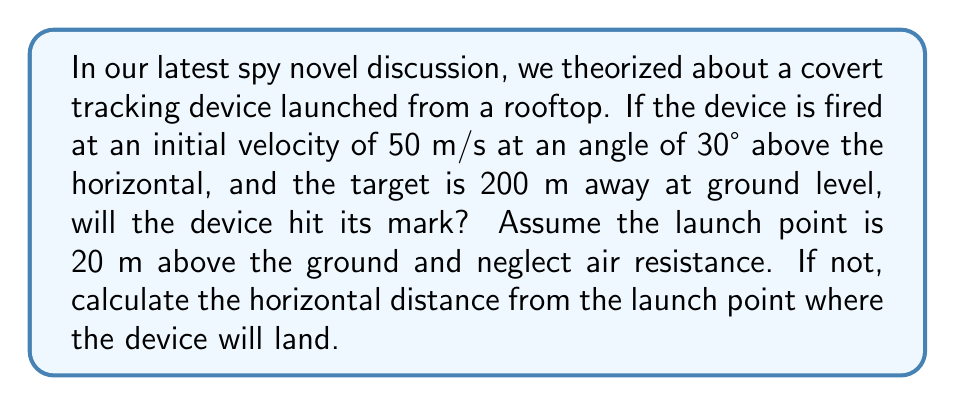Solve this math problem. Let's approach this step-by-step using projectile motion equations:

1) First, let's break down the initial velocity into its components:
   $v_{0x} = v_0 \cos \theta = 50 \cos 30° = 43.3$ m/s
   $v_{0y} = v_0 \sin \theta = 50 \sin 30° = 25$ m/s

2) The time of flight can be calculated using the vertical motion equation:
   $y = y_0 + v_{0y}t - \frac{1}{2}gt^2$
   Where $y = 0$ (ground level), $y_0 = 20$ m, $v_{0y} = 25$ m/s, and $g = 9.8$ m/s²

3) Substituting these values:
   $0 = 20 + 25t - 4.9t^2$
   $4.9t^2 - 25t - 20 = 0$

4) Solving this quadratic equation:
   $t = \frac{25 \pm \sqrt{25^2 + 4(4.9)(20)}}{2(4.9)} = \frac{25 \pm \sqrt{1225}}{9.8}$
   $t = 3.56$ seconds (we take the positive root as time can't be negative)

5) Now, we can calculate the horizontal distance traveled:
   $x = v_{0x}t = 43.3 \times 3.56 = 154.1$ m

6) The device will land 154.1 m from the launch point, which is short of the 200 m target.
Answer: 154.1 m 